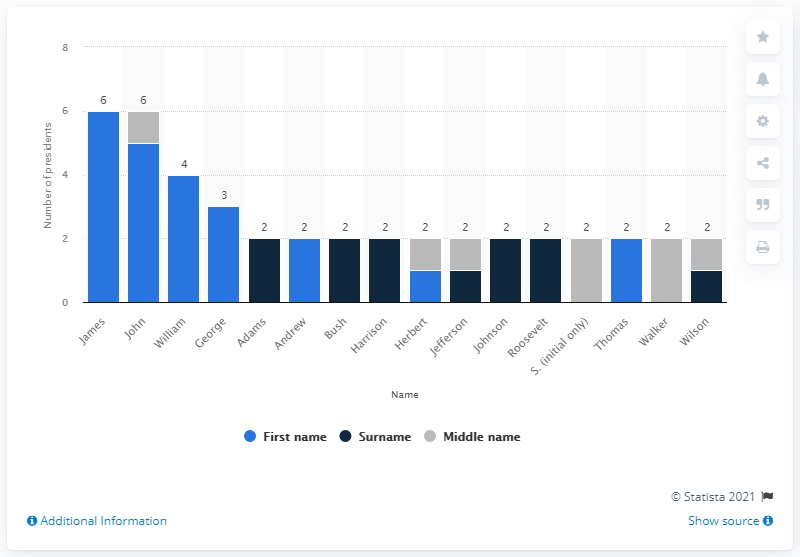Which first name has been most common among U.S. presidents? The first name 'James' has been the most common among U.S. presidents. There have been six U.S. presidents with that first name: James Madison, James Monroe, James K. Polk, James Buchanan, James Garfield, and James Carter (commonly known as Jimmy Carter). 